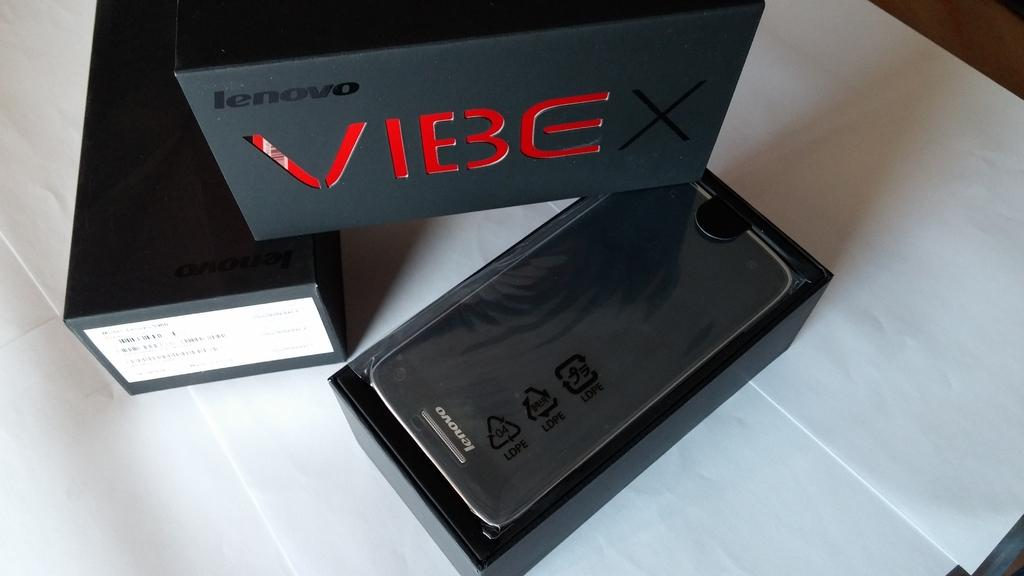<image>
Write a terse but informative summary of the picture. A lenovo phone is in a box that says Vibe. 